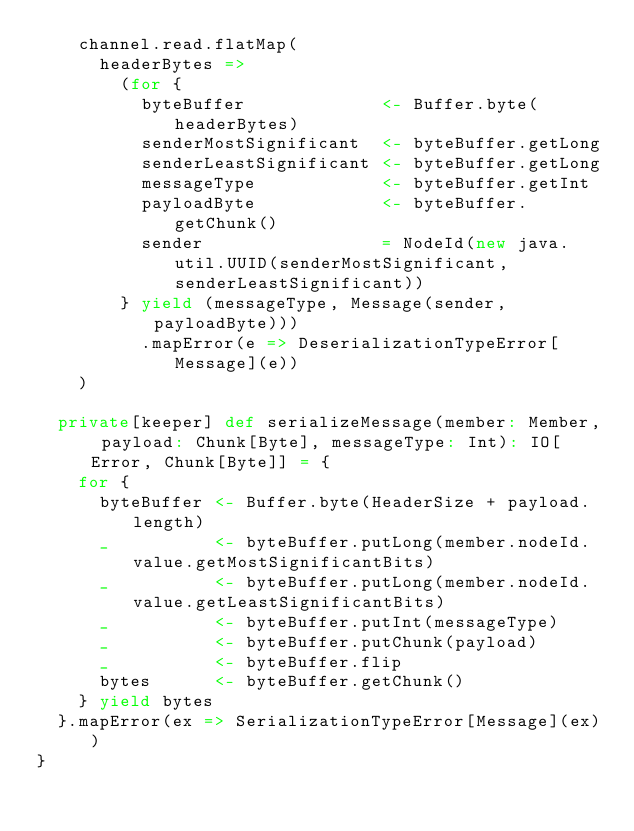<code> <loc_0><loc_0><loc_500><loc_500><_Scala_>    channel.read.flatMap(
      headerBytes =>
        (for {
          byteBuffer             <- Buffer.byte(headerBytes)
          senderMostSignificant  <- byteBuffer.getLong
          senderLeastSignificant <- byteBuffer.getLong
          messageType            <- byteBuffer.getInt
          payloadByte            <- byteBuffer.getChunk()
          sender                 = NodeId(new java.util.UUID(senderMostSignificant, senderLeastSignificant))
        } yield (messageType, Message(sender, payloadByte)))
          .mapError(e => DeserializationTypeError[Message](e))
    )

  private[keeper] def serializeMessage(member: Member, payload: Chunk[Byte], messageType: Int): IO[Error, Chunk[Byte]] = {
    for {
      byteBuffer <- Buffer.byte(HeaderSize + payload.length)
      _          <- byteBuffer.putLong(member.nodeId.value.getMostSignificantBits)
      _          <- byteBuffer.putLong(member.nodeId.value.getLeastSignificantBits)
      _          <- byteBuffer.putInt(messageType)
      _          <- byteBuffer.putChunk(payload)
      _          <- byteBuffer.flip
      bytes      <- byteBuffer.getChunk()
    } yield bytes
  }.mapError(ex => SerializationTypeError[Message](ex))
}
</code> 